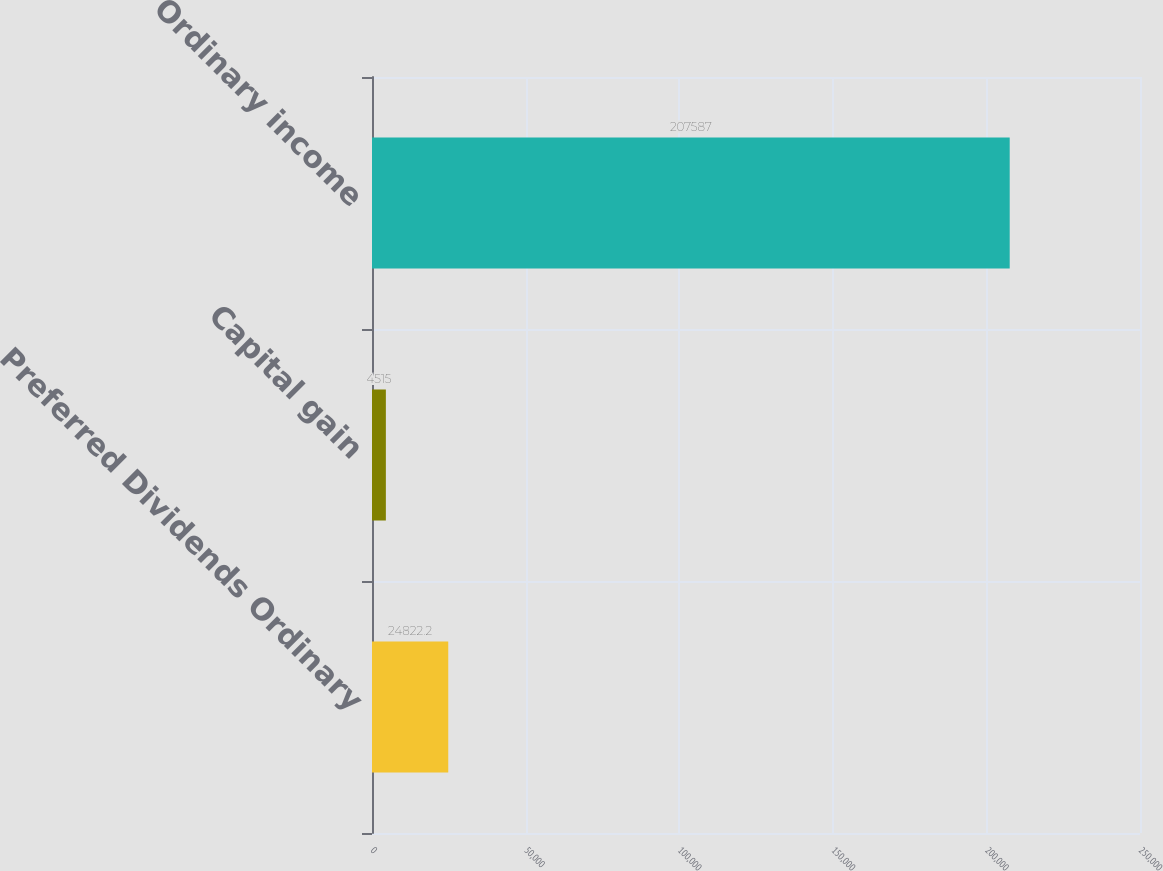Convert chart to OTSL. <chart><loc_0><loc_0><loc_500><loc_500><bar_chart><fcel>Preferred Dividends Ordinary<fcel>Capital gain<fcel>Ordinary income<nl><fcel>24822.2<fcel>4515<fcel>207587<nl></chart> 